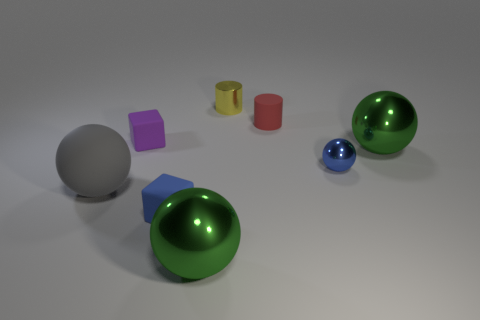There is a small thing that is both to the left of the tiny red rubber thing and on the right side of the tiny blue rubber thing; what shape is it?
Your response must be concise. Cylinder. The object that is both behind the tiny blue metallic sphere and to the right of the tiny rubber cylinder is what color?
Ensure brevity in your answer.  Green. Are there more purple rubber blocks in front of the shiny cylinder than blue metallic balls that are left of the blue block?
Make the answer very short. Yes. What is the color of the rubber block behind the gray thing?
Give a very brief answer. Purple. There is a green object that is left of the yellow cylinder; does it have the same shape as the large green shiny thing behind the large gray matte sphere?
Offer a terse response. Yes. Are there any yellow things of the same size as the matte sphere?
Provide a succinct answer. No. What material is the green sphere to the left of the small shiny cylinder?
Offer a very short reply. Metal. Is the block that is on the right side of the small purple thing made of the same material as the tiny red object?
Your answer should be very brief. Yes. Is there a green block?
Your response must be concise. No. There is another cube that is the same material as the small purple cube; what is its color?
Give a very brief answer. Blue. 